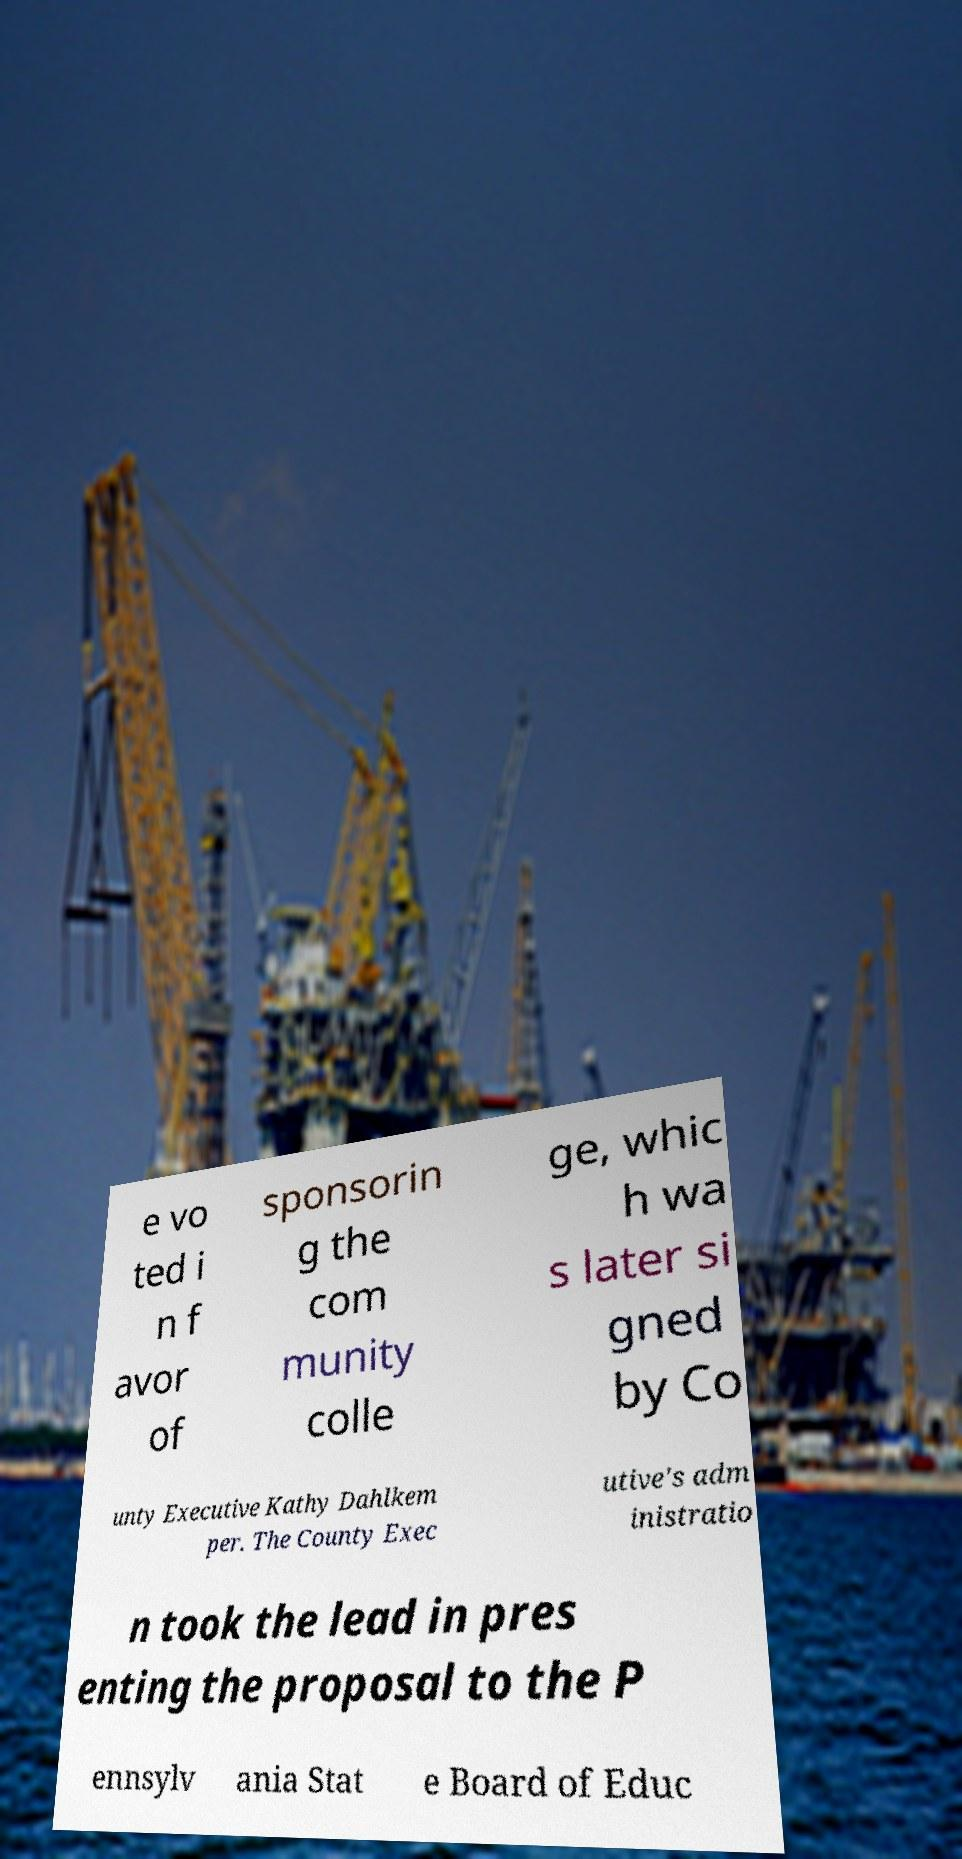I need the written content from this picture converted into text. Can you do that? e vo ted i n f avor of sponsorin g the com munity colle ge, whic h wa s later si gned by Co unty Executive Kathy Dahlkem per. The County Exec utive's adm inistratio n took the lead in pres enting the proposal to the P ennsylv ania Stat e Board of Educ 